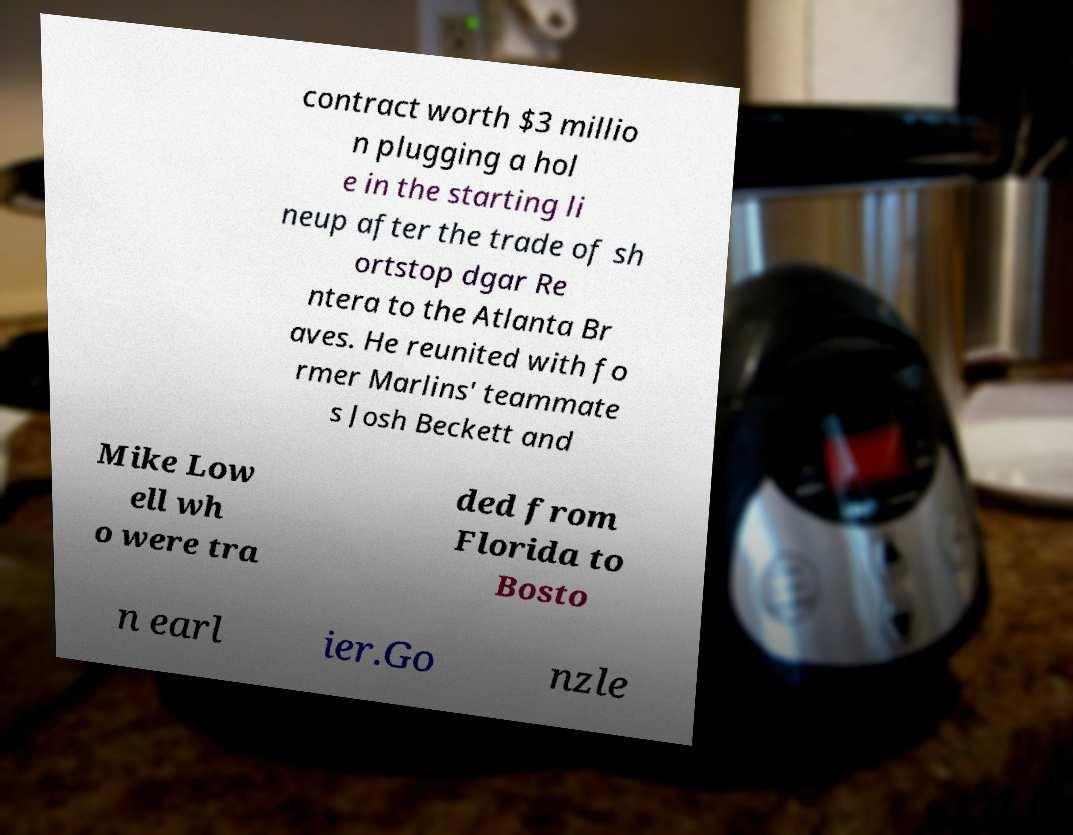Can you read and provide the text displayed in the image?This photo seems to have some interesting text. Can you extract and type it out for me? contract worth $3 millio n plugging a hol e in the starting li neup after the trade of sh ortstop dgar Re ntera to the Atlanta Br aves. He reunited with fo rmer Marlins' teammate s Josh Beckett and Mike Low ell wh o were tra ded from Florida to Bosto n earl ier.Go nzle 